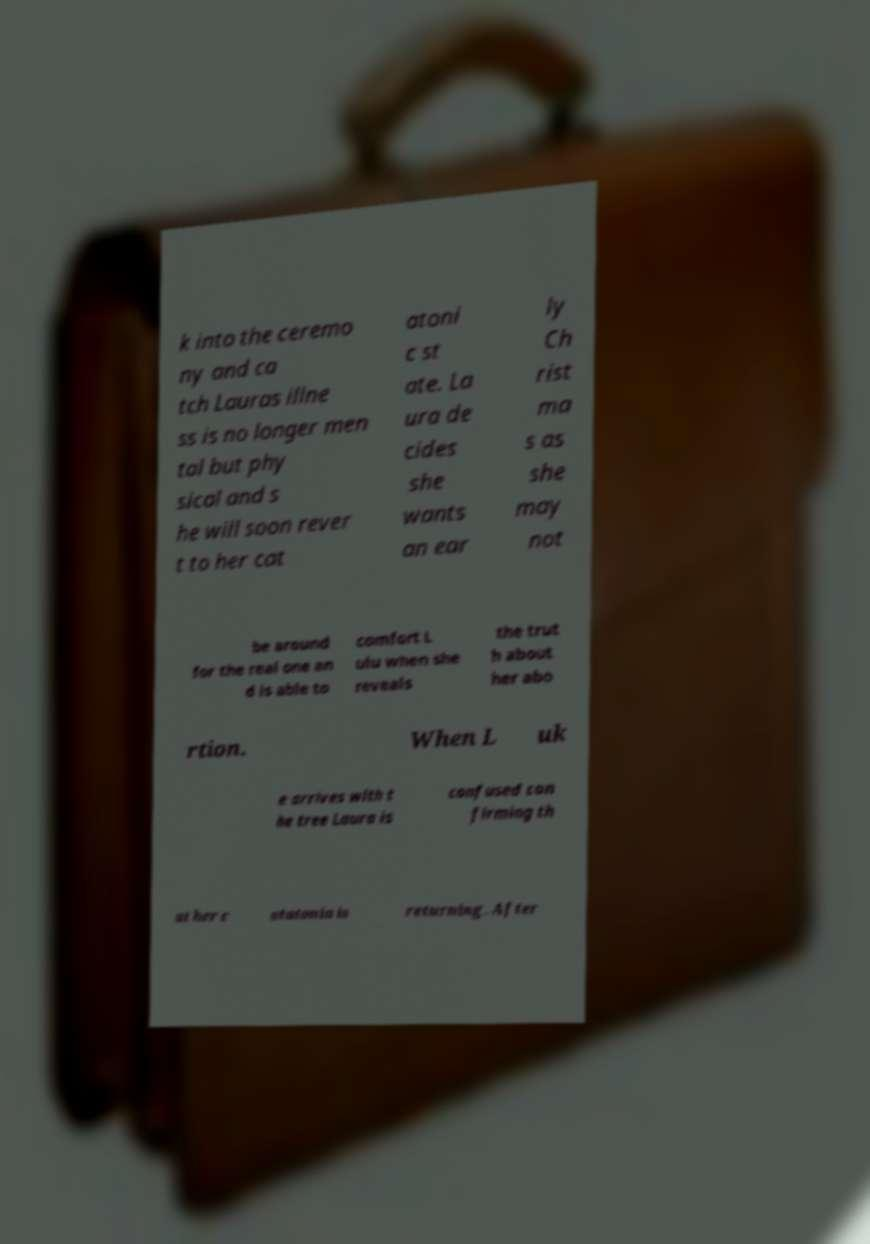Could you extract and type out the text from this image? k into the ceremo ny and ca tch Lauras illne ss is no longer men tal but phy sical and s he will soon rever t to her cat atoni c st ate. La ura de cides she wants an ear ly Ch rist ma s as she may not be around for the real one an d is able to comfort L ulu when she reveals the trut h about her abo rtion. When L uk e arrives with t he tree Laura is confused con firming th at her c atatonia is returning. After 